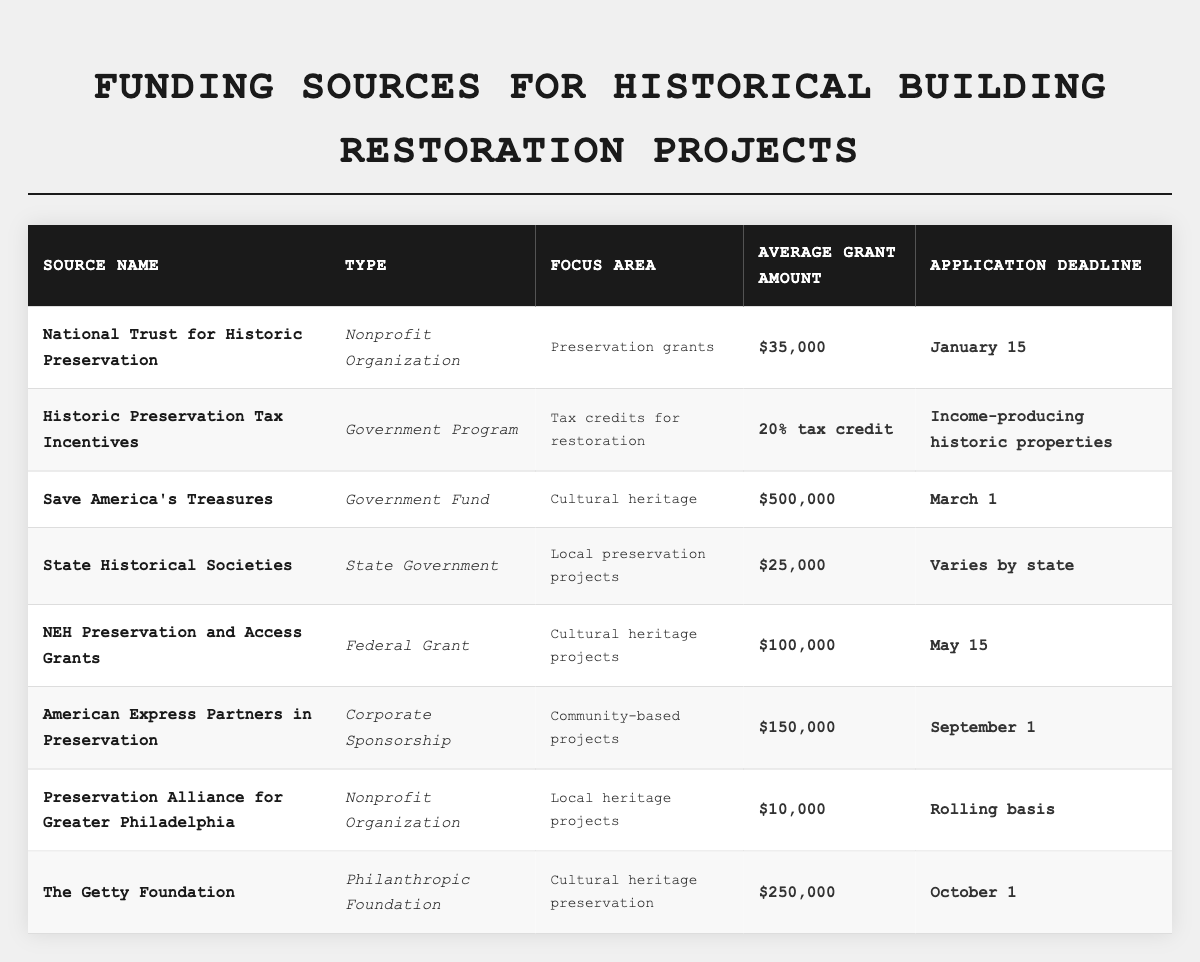What is the average grant amount offered by the National Trust for Historic Preservation? The table lists the average grant amount for the National Trust for Historic Preservation as $35,000.
Answer: $35,000 How many different types of funding sources are included in the table? The table lists a total of 8 funding sources, and they are categorized into 5 different types: Nonprofit Organization, Government Program, Government Fund, State Government, Corporate Sponsorship, and Philanthropic Foundation.
Answer: 6 Is there a funding source with a rolling application deadline? The Preservation Alliance for Greater Philadelphia is the only source listed with a rolling application deadline, confirming that such an option exists.
Answer: Yes Which funding source has the highest average grant amount? The “Save America's Treasures” funding source has the highest average grant amount of $500,000 according to the table.
Answer: $500,000 How does the average grant amount of NEH Preservation and Access Grants compare to that of the State Historical Societies? The average grant amount for NEH Preservation and Access Grants is $100,000, while for State Historical Societies, it is $25,000. Thus, NEH offers $75,000 more on average.
Answer: $75,000 more What is the application deadline for the The Getty Foundation? The table indicates that the application deadline for The Getty Foundation is October 1.
Answer: October 1 Which funding source type offers tax credits for restoration? The “Historic Preservation Tax Incentives” is identified as a Government Program that specifically focuses on providing tax credits for restoration.
Answer: Historic Preservation Tax Incentives How many funding sources have deadlines in the month of March? Only the “Save America's Treasures” funding source has a deadline in the month of March. Thus, the total is one.
Answer: 1 If you wanted to apply for funding in September, which source would you consider? The only funding source with a September application deadline is "American Express Partners in Preservation," according to the table.
Answer: American Express Partners in Preservation Is the average grant amount for the Preservation Alliance for Greater Philadelphia higher or lower than $20,000? The average grant amount for Preservation Alliance for Greater Philadelphia is $10,000, which is lower than $20,000.
Answer: Lower 